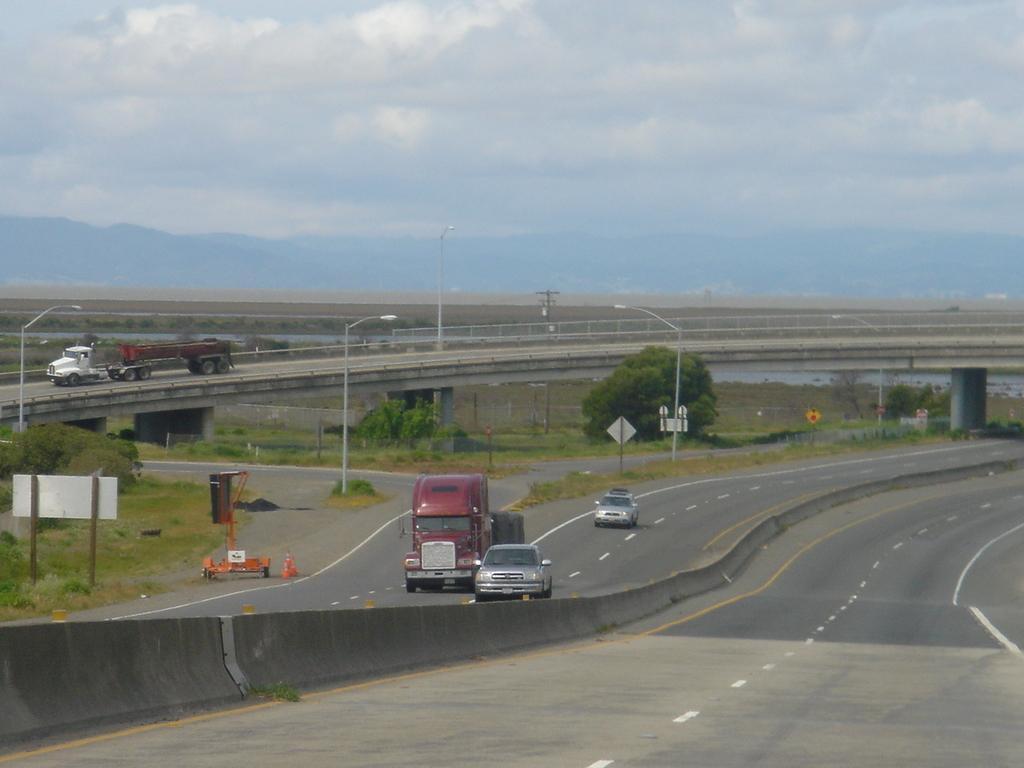Describe this image in one or two sentences. In this image we can see vehicles on the road and there are trees. We can see poles. There is a bridge. In the background we can see hills and there is sky. 